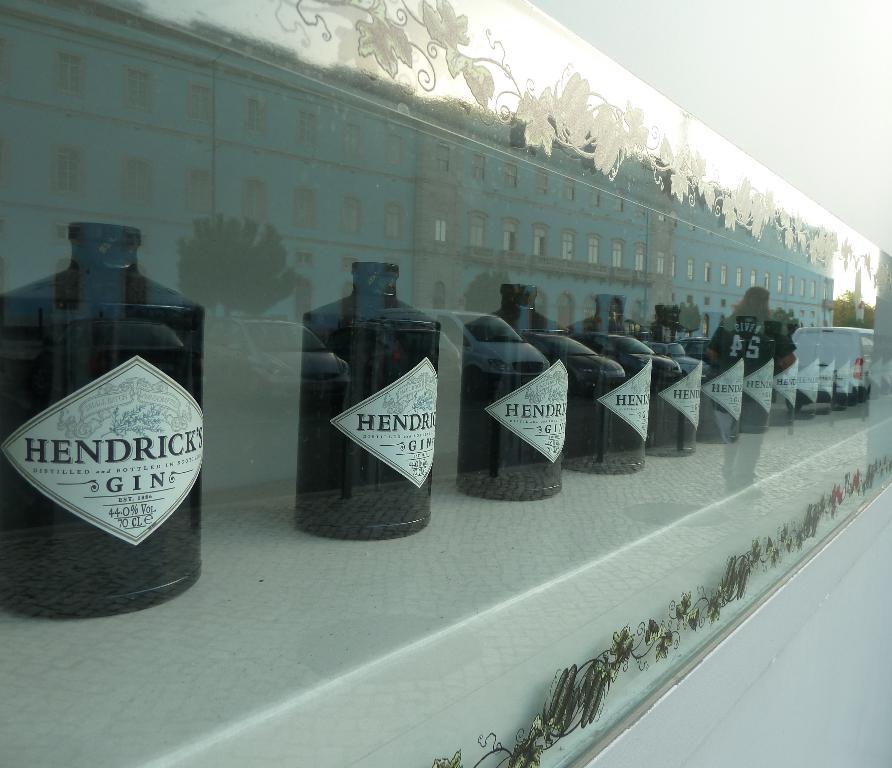How many ounces are in the bottle of gin?
Ensure brevity in your answer.  70. What type of gin?
Ensure brevity in your answer.  Hendrick's. 